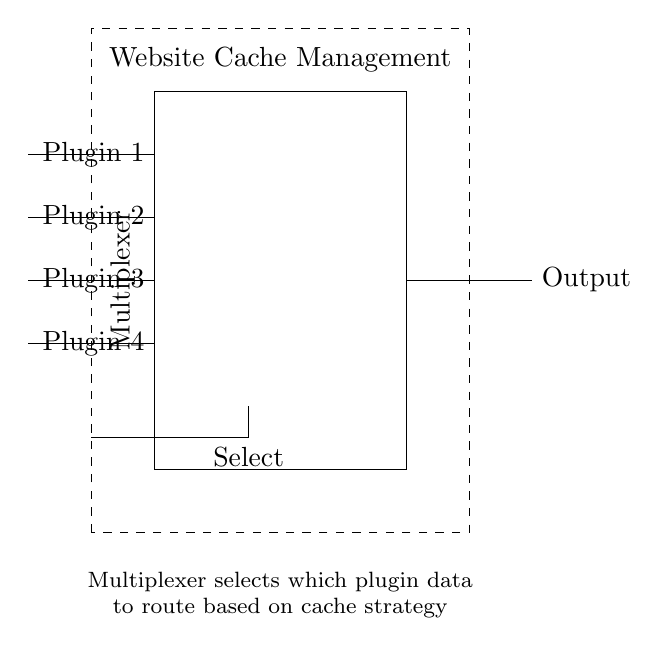What is the primary function of the multiplexer in this circuit? The primary function of the multiplexer is to route data from multiple inputs (plugins) to a single output based on select signal values.
Answer: route data How many input plugins are shown in the circuit? The circuit diagram displays four input plugins, as indicated by the four lines labeled Plugin 1 to Plugin 4.
Answer: four What does the dashed rectangle represent in the circuit? The dashed rectangle represents the control unit, which is responsible for managing the selection of the input data to be routed to the output.
Answer: control unit What does the output line connect to? The output line connects to the right side of the multiplexer, indicating the final destination of the selected plugin data.
Answer: output What is the role of the select line in the circuit? The select line determines which plugin's data is routed to the output by changing the active input line based on its signal values.
Answer: select data Which component has the label "Website Cache Management"? The dashed rectangle that illustrates the overall function of managing data caching for the plugins is labeled "Website Cache Management."
Answer: control unit 